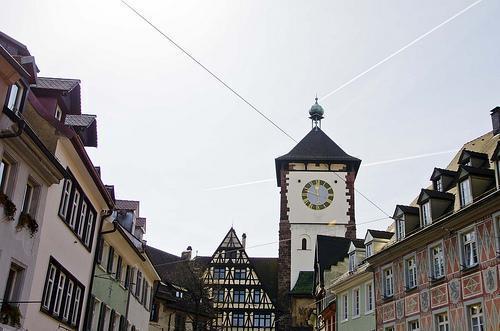How many clocks are visible?
Give a very brief answer. 1. 